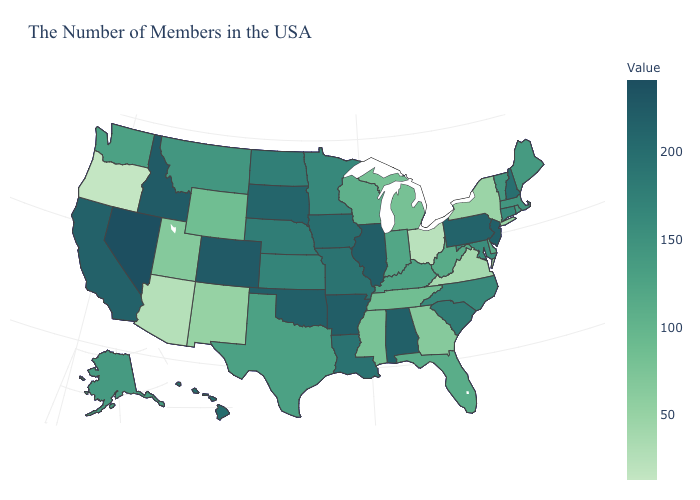Which states have the lowest value in the West?
Concise answer only. Oregon. Which states have the lowest value in the USA?
Give a very brief answer. Oregon. Does Illinois have the highest value in the MidWest?
Write a very short answer. Yes. Which states have the lowest value in the USA?
Short answer required. Oregon. Among the states that border Arkansas , does Tennessee have the highest value?
Short answer required. No. Which states have the highest value in the USA?
Write a very short answer. Nevada. 